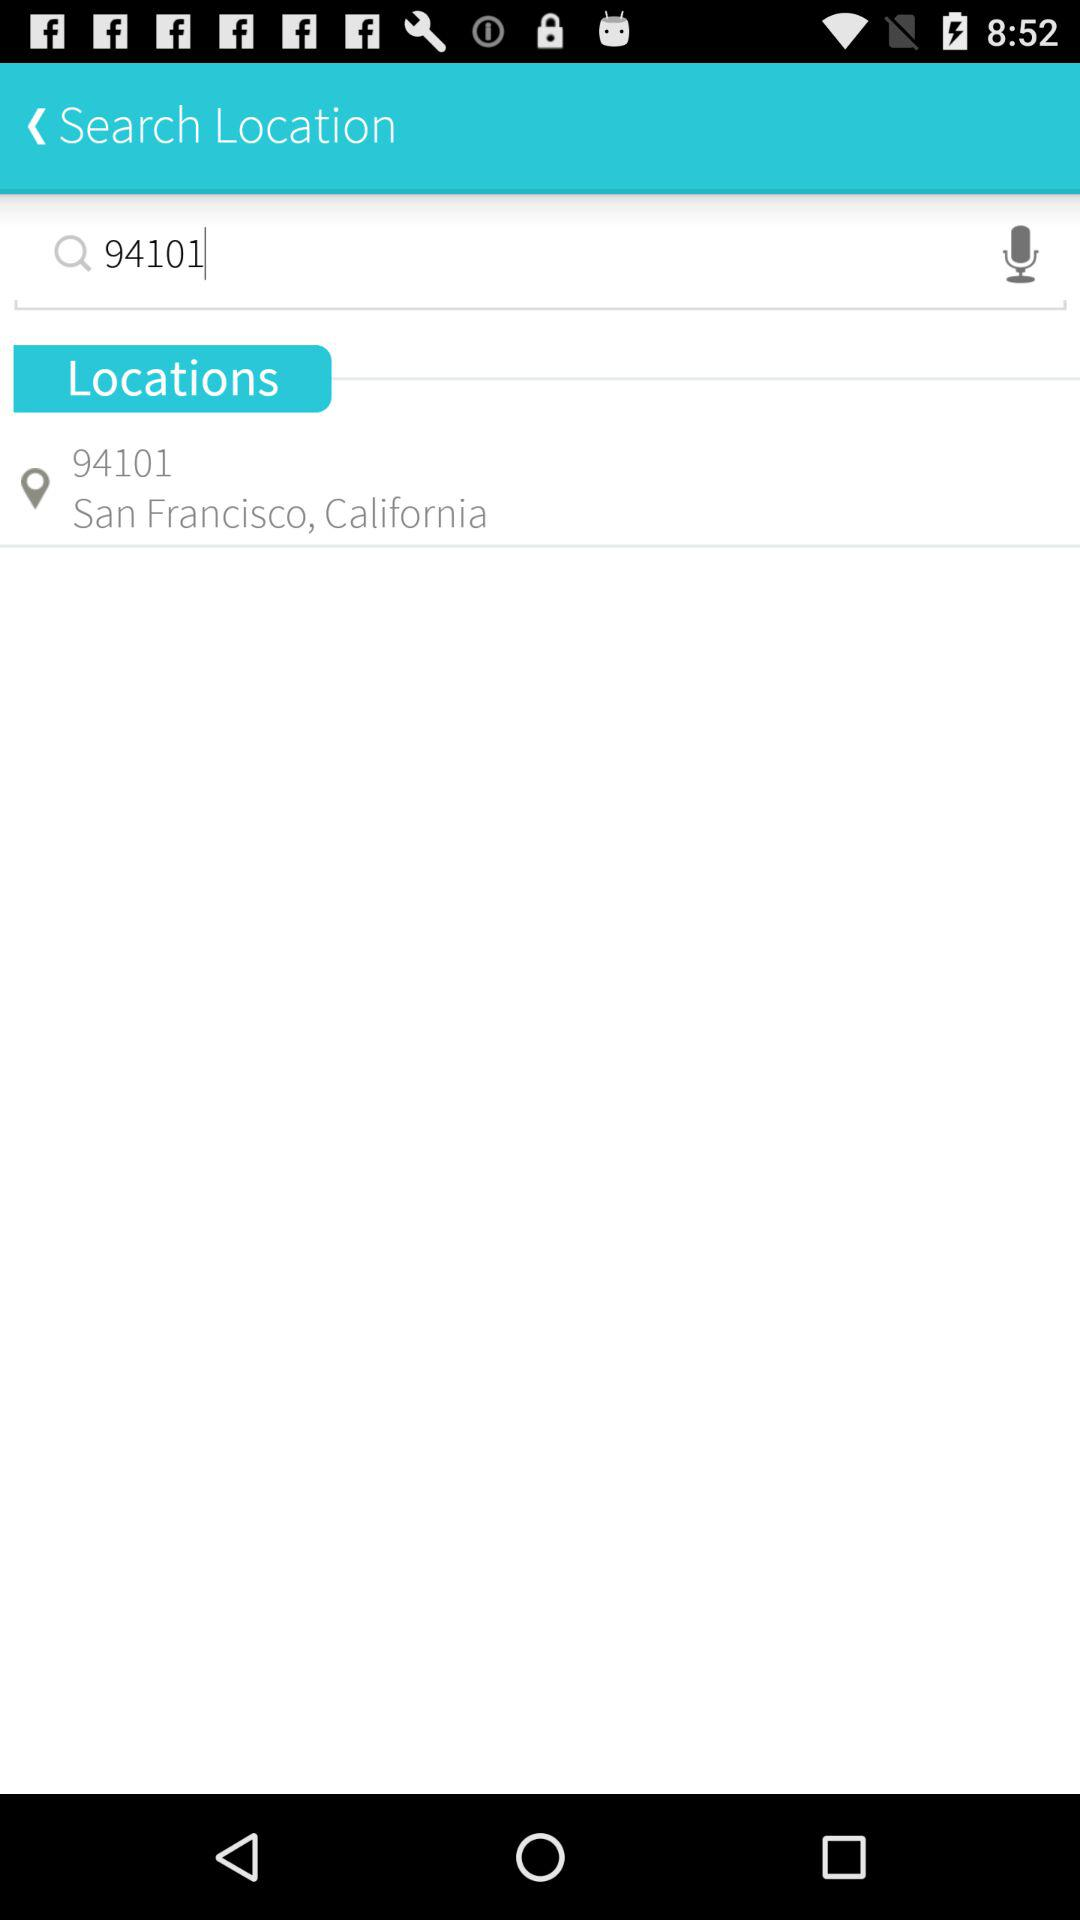What is the location? The location is 94101 San Francisco, California. 